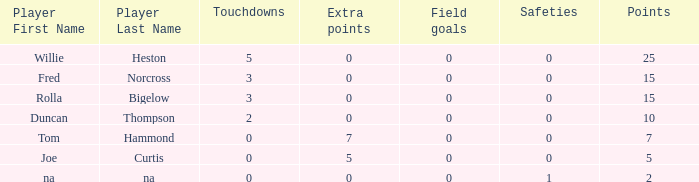Which Points is the lowest one that has Touchdowns smaller than 2, and an Extra points of 7, and a Field goals smaller than 0? None. 